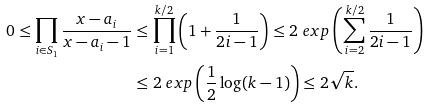Convert formula to latex. <formula><loc_0><loc_0><loc_500><loc_500>0 \leq \prod _ { i \in S _ { 1 } } \frac { x - a _ { i } } { x - a _ { i } - 1 } & \leq \prod _ { i = 1 } ^ { k / 2 } \left ( 1 + \frac { 1 } { 2 i - 1 } \right ) \leq 2 \ e x p \left ( \sum _ { i = 2 } ^ { k / 2 } \frac { 1 } { 2 i - 1 } \right ) \\ & \leq 2 \ e x p \left ( \frac { 1 } { 2 } \log ( k - 1 ) \right ) \leq 2 \sqrt { k } .</formula> 